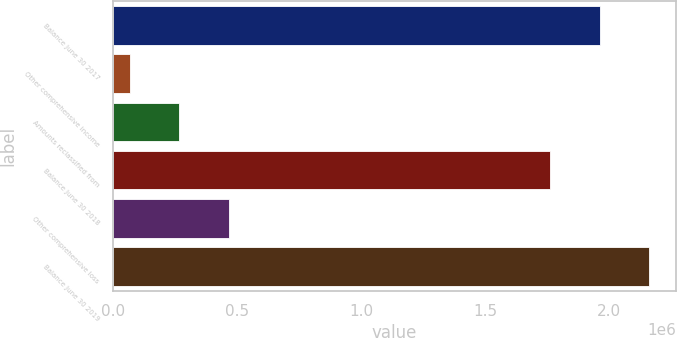Convert chart. <chart><loc_0><loc_0><loc_500><loc_500><bar_chart><fcel>Balance June 30 2017<fcel>Other comprehensive income<fcel>Amounts reclassified from<fcel>Balance June 30 2018<fcel>Other comprehensive loss<fcel>Balance June 30 2019<nl><fcel>1.96236e+06<fcel>66276<fcel>265553<fcel>1.76309e+06<fcel>464830<fcel>2.16164e+06<nl></chart> 